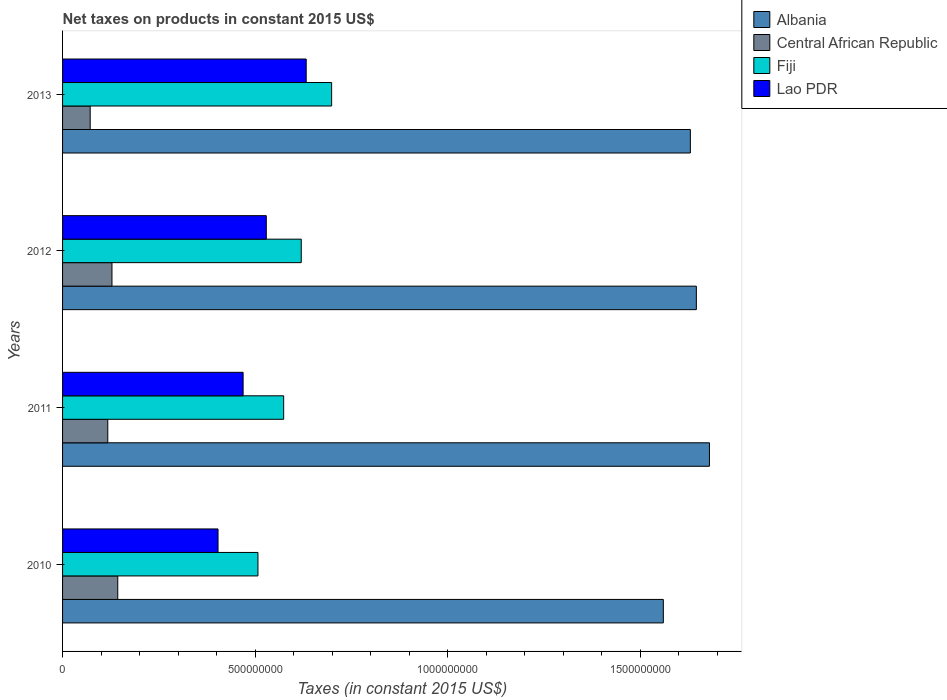How many different coloured bars are there?
Your response must be concise. 4. How many groups of bars are there?
Offer a very short reply. 4. Are the number of bars per tick equal to the number of legend labels?
Ensure brevity in your answer.  Yes. Are the number of bars on each tick of the Y-axis equal?
Offer a terse response. Yes. How many bars are there on the 1st tick from the top?
Ensure brevity in your answer.  4. What is the label of the 1st group of bars from the top?
Give a very brief answer. 2013. What is the net taxes on products in Albania in 2010?
Your answer should be compact. 1.56e+09. Across all years, what is the maximum net taxes on products in Central African Republic?
Keep it short and to the point. 1.43e+08. Across all years, what is the minimum net taxes on products in Lao PDR?
Your response must be concise. 4.04e+08. In which year was the net taxes on products in Albania maximum?
Ensure brevity in your answer.  2011. In which year was the net taxes on products in Central African Republic minimum?
Provide a short and direct response. 2013. What is the total net taxes on products in Fiji in the graph?
Your response must be concise. 2.40e+09. What is the difference between the net taxes on products in Fiji in 2012 and that in 2013?
Offer a very short reply. -7.89e+07. What is the difference between the net taxes on products in Fiji in 2011 and the net taxes on products in Central African Republic in 2012?
Give a very brief answer. 4.46e+08. What is the average net taxes on products in Albania per year?
Ensure brevity in your answer.  1.63e+09. In the year 2012, what is the difference between the net taxes on products in Central African Republic and net taxes on products in Lao PDR?
Make the answer very short. -4.01e+08. In how many years, is the net taxes on products in Central African Republic greater than 700000000 US$?
Provide a short and direct response. 0. What is the ratio of the net taxes on products in Fiji in 2011 to that in 2013?
Provide a short and direct response. 0.82. Is the net taxes on products in Lao PDR in 2010 less than that in 2011?
Provide a short and direct response. Yes. What is the difference between the highest and the second highest net taxes on products in Albania?
Your answer should be very brief. 3.41e+07. What is the difference between the highest and the lowest net taxes on products in Fiji?
Offer a terse response. 1.91e+08. Is it the case that in every year, the sum of the net taxes on products in Lao PDR and net taxes on products in Fiji is greater than the sum of net taxes on products in Central African Republic and net taxes on products in Albania?
Keep it short and to the point. No. What does the 2nd bar from the top in 2011 represents?
Your answer should be compact. Fiji. What does the 4th bar from the bottom in 2011 represents?
Your answer should be compact. Lao PDR. Is it the case that in every year, the sum of the net taxes on products in Fiji and net taxes on products in Central African Republic is greater than the net taxes on products in Albania?
Give a very brief answer. No. What is the difference between two consecutive major ticks on the X-axis?
Offer a terse response. 5.00e+08. Are the values on the major ticks of X-axis written in scientific E-notation?
Ensure brevity in your answer.  No. Does the graph contain any zero values?
Your answer should be compact. No. Does the graph contain grids?
Offer a terse response. No. Where does the legend appear in the graph?
Offer a very short reply. Top right. How many legend labels are there?
Provide a succinct answer. 4. What is the title of the graph?
Keep it short and to the point. Net taxes on products in constant 2015 US$. Does "Afghanistan" appear as one of the legend labels in the graph?
Give a very brief answer. No. What is the label or title of the X-axis?
Offer a very short reply. Taxes (in constant 2015 US$). What is the Taxes (in constant 2015 US$) of Albania in 2010?
Offer a terse response. 1.56e+09. What is the Taxes (in constant 2015 US$) in Central African Republic in 2010?
Your answer should be very brief. 1.43e+08. What is the Taxes (in constant 2015 US$) of Fiji in 2010?
Offer a terse response. 5.07e+08. What is the Taxes (in constant 2015 US$) of Lao PDR in 2010?
Offer a very short reply. 4.04e+08. What is the Taxes (in constant 2015 US$) in Albania in 2011?
Your response must be concise. 1.68e+09. What is the Taxes (in constant 2015 US$) in Central African Republic in 2011?
Make the answer very short. 1.17e+08. What is the Taxes (in constant 2015 US$) of Fiji in 2011?
Keep it short and to the point. 5.74e+08. What is the Taxes (in constant 2015 US$) of Lao PDR in 2011?
Keep it short and to the point. 4.69e+08. What is the Taxes (in constant 2015 US$) in Albania in 2012?
Keep it short and to the point. 1.65e+09. What is the Taxes (in constant 2015 US$) in Central African Republic in 2012?
Offer a terse response. 1.28e+08. What is the Taxes (in constant 2015 US$) in Fiji in 2012?
Your response must be concise. 6.20e+08. What is the Taxes (in constant 2015 US$) in Lao PDR in 2012?
Offer a very short reply. 5.29e+08. What is the Taxes (in constant 2015 US$) in Albania in 2013?
Ensure brevity in your answer.  1.63e+09. What is the Taxes (in constant 2015 US$) in Central African Republic in 2013?
Keep it short and to the point. 7.17e+07. What is the Taxes (in constant 2015 US$) of Fiji in 2013?
Ensure brevity in your answer.  6.99e+08. What is the Taxes (in constant 2015 US$) of Lao PDR in 2013?
Give a very brief answer. 6.33e+08. Across all years, what is the maximum Taxes (in constant 2015 US$) in Albania?
Your answer should be very brief. 1.68e+09. Across all years, what is the maximum Taxes (in constant 2015 US$) of Central African Republic?
Make the answer very short. 1.43e+08. Across all years, what is the maximum Taxes (in constant 2015 US$) of Fiji?
Your answer should be compact. 6.99e+08. Across all years, what is the maximum Taxes (in constant 2015 US$) in Lao PDR?
Your answer should be very brief. 6.33e+08. Across all years, what is the minimum Taxes (in constant 2015 US$) in Albania?
Your answer should be compact. 1.56e+09. Across all years, what is the minimum Taxes (in constant 2015 US$) of Central African Republic?
Ensure brevity in your answer.  7.17e+07. Across all years, what is the minimum Taxes (in constant 2015 US$) in Fiji?
Make the answer very short. 5.07e+08. Across all years, what is the minimum Taxes (in constant 2015 US$) in Lao PDR?
Ensure brevity in your answer.  4.04e+08. What is the total Taxes (in constant 2015 US$) in Albania in the graph?
Your answer should be very brief. 6.52e+09. What is the total Taxes (in constant 2015 US$) in Central African Republic in the graph?
Provide a succinct answer. 4.61e+08. What is the total Taxes (in constant 2015 US$) in Fiji in the graph?
Keep it short and to the point. 2.40e+09. What is the total Taxes (in constant 2015 US$) in Lao PDR in the graph?
Provide a succinct answer. 2.03e+09. What is the difference between the Taxes (in constant 2015 US$) of Albania in 2010 and that in 2011?
Your answer should be compact. -1.20e+08. What is the difference between the Taxes (in constant 2015 US$) of Central African Republic in 2010 and that in 2011?
Your answer should be compact. 2.59e+07. What is the difference between the Taxes (in constant 2015 US$) in Fiji in 2010 and that in 2011?
Your answer should be very brief. -6.68e+07. What is the difference between the Taxes (in constant 2015 US$) of Lao PDR in 2010 and that in 2011?
Make the answer very short. -6.51e+07. What is the difference between the Taxes (in constant 2015 US$) of Albania in 2010 and that in 2012?
Make the answer very short. -8.57e+07. What is the difference between the Taxes (in constant 2015 US$) of Central African Republic in 2010 and that in 2012?
Offer a very short reply. 1.51e+07. What is the difference between the Taxes (in constant 2015 US$) in Fiji in 2010 and that in 2012?
Give a very brief answer. -1.12e+08. What is the difference between the Taxes (in constant 2015 US$) of Lao PDR in 2010 and that in 2012?
Provide a succinct answer. -1.25e+08. What is the difference between the Taxes (in constant 2015 US$) of Albania in 2010 and that in 2013?
Ensure brevity in your answer.  -7.02e+07. What is the difference between the Taxes (in constant 2015 US$) of Central African Republic in 2010 and that in 2013?
Provide a succinct answer. 7.16e+07. What is the difference between the Taxes (in constant 2015 US$) of Fiji in 2010 and that in 2013?
Your response must be concise. -1.91e+08. What is the difference between the Taxes (in constant 2015 US$) of Lao PDR in 2010 and that in 2013?
Offer a terse response. -2.29e+08. What is the difference between the Taxes (in constant 2015 US$) of Albania in 2011 and that in 2012?
Provide a succinct answer. 3.41e+07. What is the difference between the Taxes (in constant 2015 US$) of Central African Republic in 2011 and that in 2012?
Ensure brevity in your answer.  -1.09e+07. What is the difference between the Taxes (in constant 2015 US$) of Fiji in 2011 and that in 2012?
Your answer should be compact. -4.56e+07. What is the difference between the Taxes (in constant 2015 US$) of Lao PDR in 2011 and that in 2012?
Give a very brief answer. -6.02e+07. What is the difference between the Taxes (in constant 2015 US$) of Albania in 2011 and that in 2013?
Provide a short and direct response. 4.96e+07. What is the difference between the Taxes (in constant 2015 US$) in Central African Republic in 2011 and that in 2013?
Offer a terse response. 4.57e+07. What is the difference between the Taxes (in constant 2015 US$) in Fiji in 2011 and that in 2013?
Your answer should be compact. -1.25e+08. What is the difference between the Taxes (in constant 2015 US$) of Lao PDR in 2011 and that in 2013?
Your answer should be very brief. -1.64e+08. What is the difference between the Taxes (in constant 2015 US$) of Albania in 2012 and that in 2013?
Ensure brevity in your answer.  1.55e+07. What is the difference between the Taxes (in constant 2015 US$) of Central African Republic in 2012 and that in 2013?
Your answer should be compact. 5.66e+07. What is the difference between the Taxes (in constant 2015 US$) of Fiji in 2012 and that in 2013?
Keep it short and to the point. -7.89e+07. What is the difference between the Taxes (in constant 2015 US$) in Lao PDR in 2012 and that in 2013?
Ensure brevity in your answer.  -1.04e+08. What is the difference between the Taxes (in constant 2015 US$) of Albania in 2010 and the Taxes (in constant 2015 US$) of Central African Republic in 2011?
Ensure brevity in your answer.  1.44e+09. What is the difference between the Taxes (in constant 2015 US$) in Albania in 2010 and the Taxes (in constant 2015 US$) in Fiji in 2011?
Your response must be concise. 9.86e+08. What is the difference between the Taxes (in constant 2015 US$) in Albania in 2010 and the Taxes (in constant 2015 US$) in Lao PDR in 2011?
Offer a terse response. 1.09e+09. What is the difference between the Taxes (in constant 2015 US$) of Central African Republic in 2010 and the Taxes (in constant 2015 US$) of Fiji in 2011?
Keep it short and to the point. -4.31e+08. What is the difference between the Taxes (in constant 2015 US$) in Central African Republic in 2010 and the Taxes (in constant 2015 US$) in Lao PDR in 2011?
Provide a succinct answer. -3.26e+08. What is the difference between the Taxes (in constant 2015 US$) of Fiji in 2010 and the Taxes (in constant 2015 US$) of Lao PDR in 2011?
Make the answer very short. 3.86e+07. What is the difference between the Taxes (in constant 2015 US$) of Albania in 2010 and the Taxes (in constant 2015 US$) of Central African Republic in 2012?
Make the answer very short. 1.43e+09. What is the difference between the Taxes (in constant 2015 US$) in Albania in 2010 and the Taxes (in constant 2015 US$) in Fiji in 2012?
Give a very brief answer. 9.40e+08. What is the difference between the Taxes (in constant 2015 US$) of Albania in 2010 and the Taxes (in constant 2015 US$) of Lao PDR in 2012?
Provide a succinct answer. 1.03e+09. What is the difference between the Taxes (in constant 2015 US$) of Central African Republic in 2010 and the Taxes (in constant 2015 US$) of Fiji in 2012?
Your answer should be very brief. -4.77e+08. What is the difference between the Taxes (in constant 2015 US$) of Central African Republic in 2010 and the Taxes (in constant 2015 US$) of Lao PDR in 2012?
Your response must be concise. -3.86e+08. What is the difference between the Taxes (in constant 2015 US$) of Fiji in 2010 and the Taxes (in constant 2015 US$) of Lao PDR in 2012?
Your response must be concise. -2.17e+07. What is the difference between the Taxes (in constant 2015 US$) of Albania in 2010 and the Taxes (in constant 2015 US$) of Central African Republic in 2013?
Your answer should be compact. 1.49e+09. What is the difference between the Taxes (in constant 2015 US$) in Albania in 2010 and the Taxes (in constant 2015 US$) in Fiji in 2013?
Your answer should be compact. 8.61e+08. What is the difference between the Taxes (in constant 2015 US$) of Albania in 2010 and the Taxes (in constant 2015 US$) of Lao PDR in 2013?
Your response must be concise. 9.27e+08. What is the difference between the Taxes (in constant 2015 US$) in Central African Republic in 2010 and the Taxes (in constant 2015 US$) in Fiji in 2013?
Offer a terse response. -5.55e+08. What is the difference between the Taxes (in constant 2015 US$) in Central African Republic in 2010 and the Taxes (in constant 2015 US$) in Lao PDR in 2013?
Your answer should be compact. -4.89e+08. What is the difference between the Taxes (in constant 2015 US$) of Fiji in 2010 and the Taxes (in constant 2015 US$) of Lao PDR in 2013?
Make the answer very short. -1.25e+08. What is the difference between the Taxes (in constant 2015 US$) of Albania in 2011 and the Taxes (in constant 2015 US$) of Central African Republic in 2012?
Offer a very short reply. 1.55e+09. What is the difference between the Taxes (in constant 2015 US$) in Albania in 2011 and the Taxes (in constant 2015 US$) in Fiji in 2012?
Provide a short and direct response. 1.06e+09. What is the difference between the Taxes (in constant 2015 US$) in Albania in 2011 and the Taxes (in constant 2015 US$) in Lao PDR in 2012?
Give a very brief answer. 1.15e+09. What is the difference between the Taxes (in constant 2015 US$) of Central African Republic in 2011 and the Taxes (in constant 2015 US$) of Fiji in 2012?
Provide a short and direct response. -5.02e+08. What is the difference between the Taxes (in constant 2015 US$) of Central African Republic in 2011 and the Taxes (in constant 2015 US$) of Lao PDR in 2012?
Keep it short and to the point. -4.12e+08. What is the difference between the Taxes (in constant 2015 US$) in Fiji in 2011 and the Taxes (in constant 2015 US$) in Lao PDR in 2012?
Keep it short and to the point. 4.51e+07. What is the difference between the Taxes (in constant 2015 US$) in Albania in 2011 and the Taxes (in constant 2015 US$) in Central African Republic in 2013?
Offer a very short reply. 1.61e+09. What is the difference between the Taxes (in constant 2015 US$) of Albania in 2011 and the Taxes (in constant 2015 US$) of Fiji in 2013?
Keep it short and to the point. 9.81e+08. What is the difference between the Taxes (in constant 2015 US$) of Albania in 2011 and the Taxes (in constant 2015 US$) of Lao PDR in 2013?
Your response must be concise. 1.05e+09. What is the difference between the Taxes (in constant 2015 US$) in Central African Republic in 2011 and the Taxes (in constant 2015 US$) in Fiji in 2013?
Give a very brief answer. -5.81e+08. What is the difference between the Taxes (in constant 2015 US$) in Central African Republic in 2011 and the Taxes (in constant 2015 US$) in Lao PDR in 2013?
Keep it short and to the point. -5.15e+08. What is the difference between the Taxes (in constant 2015 US$) in Fiji in 2011 and the Taxes (in constant 2015 US$) in Lao PDR in 2013?
Make the answer very short. -5.85e+07. What is the difference between the Taxes (in constant 2015 US$) of Albania in 2012 and the Taxes (in constant 2015 US$) of Central African Republic in 2013?
Provide a short and direct response. 1.57e+09. What is the difference between the Taxes (in constant 2015 US$) in Albania in 2012 and the Taxes (in constant 2015 US$) in Fiji in 2013?
Your response must be concise. 9.47e+08. What is the difference between the Taxes (in constant 2015 US$) of Albania in 2012 and the Taxes (in constant 2015 US$) of Lao PDR in 2013?
Your answer should be compact. 1.01e+09. What is the difference between the Taxes (in constant 2015 US$) in Central African Republic in 2012 and the Taxes (in constant 2015 US$) in Fiji in 2013?
Make the answer very short. -5.70e+08. What is the difference between the Taxes (in constant 2015 US$) in Central African Republic in 2012 and the Taxes (in constant 2015 US$) in Lao PDR in 2013?
Keep it short and to the point. -5.04e+08. What is the difference between the Taxes (in constant 2015 US$) of Fiji in 2012 and the Taxes (in constant 2015 US$) of Lao PDR in 2013?
Ensure brevity in your answer.  -1.29e+07. What is the average Taxes (in constant 2015 US$) in Albania per year?
Keep it short and to the point. 1.63e+09. What is the average Taxes (in constant 2015 US$) in Central African Republic per year?
Offer a terse response. 1.15e+08. What is the average Taxes (in constant 2015 US$) of Fiji per year?
Ensure brevity in your answer.  6.00e+08. What is the average Taxes (in constant 2015 US$) of Lao PDR per year?
Ensure brevity in your answer.  5.09e+08. In the year 2010, what is the difference between the Taxes (in constant 2015 US$) of Albania and Taxes (in constant 2015 US$) of Central African Republic?
Provide a short and direct response. 1.42e+09. In the year 2010, what is the difference between the Taxes (in constant 2015 US$) of Albania and Taxes (in constant 2015 US$) of Fiji?
Provide a succinct answer. 1.05e+09. In the year 2010, what is the difference between the Taxes (in constant 2015 US$) of Albania and Taxes (in constant 2015 US$) of Lao PDR?
Give a very brief answer. 1.16e+09. In the year 2010, what is the difference between the Taxes (in constant 2015 US$) of Central African Republic and Taxes (in constant 2015 US$) of Fiji?
Give a very brief answer. -3.64e+08. In the year 2010, what is the difference between the Taxes (in constant 2015 US$) in Central African Republic and Taxes (in constant 2015 US$) in Lao PDR?
Provide a short and direct response. -2.60e+08. In the year 2010, what is the difference between the Taxes (in constant 2015 US$) in Fiji and Taxes (in constant 2015 US$) in Lao PDR?
Your response must be concise. 1.04e+08. In the year 2011, what is the difference between the Taxes (in constant 2015 US$) of Albania and Taxes (in constant 2015 US$) of Central African Republic?
Offer a very short reply. 1.56e+09. In the year 2011, what is the difference between the Taxes (in constant 2015 US$) of Albania and Taxes (in constant 2015 US$) of Fiji?
Your response must be concise. 1.11e+09. In the year 2011, what is the difference between the Taxes (in constant 2015 US$) in Albania and Taxes (in constant 2015 US$) in Lao PDR?
Your response must be concise. 1.21e+09. In the year 2011, what is the difference between the Taxes (in constant 2015 US$) of Central African Republic and Taxes (in constant 2015 US$) of Fiji?
Your answer should be very brief. -4.57e+08. In the year 2011, what is the difference between the Taxes (in constant 2015 US$) of Central African Republic and Taxes (in constant 2015 US$) of Lao PDR?
Ensure brevity in your answer.  -3.51e+08. In the year 2011, what is the difference between the Taxes (in constant 2015 US$) of Fiji and Taxes (in constant 2015 US$) of Lao PDR?
Give a very brief answer. 1.05e+08. In the year 2012, what is the difference between the Taxes (in constant 2015 US$) of Albania and Taxes (in constant 2015 US$) of Central African Republic?
Your answer should be very brief. 1.52e+09. In the year 2012, what is the difference between the Taxes (in constant 2015 US$) in Albania and Taxes (in constant 2015 US$) in Fiji?
Your answer should be very brief. 1.03e+09. In the year 2012, what is the difference between the Taxes (in constant 2015 US$) of Albania and Taxes (in constant 2015 US$) of Lao PDR?
Give a very brief answer. 1.12e+09. In the year 2012, what is the difference between the Taxes (in constant 2015 US$) of Central African Republic and Taxes (in constant 2015 US$) of Fiji?
Your answer should be very brief. -4.92e+08. In the year 2012, what is the difference between the Taxes (in constant 2015 US$) in Central African Republic and Taxes (in constant 2015 US$) in Lao PDR?
Ensure brevity in your answer.  -4.01e+08. In the year 2012, what is the difference between the Taxes (in constant 2015 US$) of Fiji and Taxes (in constant 2015 US$) of Lao PDR?
Offer a terse response. 9.08e+07. In the year 2013, what is the difference between the Taxes (in constant 2015 US$) in Albania and Taxes (in constant 2015 US$) in Central African Republic?
Keep it short and to the point. 1.56e+09. In the year 2013, what is the difference between the Taxes (in constant 2015 US$) of Albania and Taxes (in constant 2015 US$) of Fiji?
Offer a terse response. 9.32e+08. In the year 2013, what is the difference between the Taxes (in constant 2015 US$) of Albania and Taxes (in constant 2015 US$) of Lao PDR?
Give a very brief answer. 9.98e+08. In the year 2013, what is the difference between the Taxes (in constant 2015 US$) of Central African Republic and Taxes (in constant 2015 US$) of Fiji?
Ensure brevity in your answer.  -6.27e+08. In the year 2013, what is the difference between the Taxes (in constant 2015 US$) in Central African Republic and Taxes (in constant 2015 US$) in Lao PDR?
Offer a very short reply. -5.61e+08. In the year 2013, what is the difference between the Taxes (in constant 2015 US$) of Fiji and Taxes (in constant 2015 US$) of Lao PDR?
Offer a terse response. 6.60e+07. What is the ratio of the Taxes (in constant 2015 US$) of Albania in 2010 to that in 2011?
Provide a short and direct response. 0.93. What is the ratio of the Taxes (in constant 2015 US$) in Central African Republic in 2010 to that in 2011?
Make the answer very short. 1.22. What is the ratio of the Taxes (in constant 2015 US$) in Fiji in 2010 to that in 2011?
Give a very brief answer. 0.88. What is the ratio of the Taxes (in constant 2015 US$) of Lao PDR in 2010 to that in 2011?
Your response must be concise. 0.86. What is the ratio of the Taxes (in constant 2015 US$) of Albania in 2010 to that in 2012?
Keep it short and to the point. 0.95. What is the ratio of the Taxes (in constant 2015 US$) in Central African Republic in 2010 to that in 2012?
Offer a terse response. 1.12. What is the ratio of the Taxes (in constant 2015 US$) of Fiji in 2010 to that in 2012?
Make the answer very short. 0.82. What is the ratio of the Taxes (in constant 2015 US$) in Lao PDR in 2010 to that in 2012?
Your answer should be very brief. 0.76. What is the ratio of the Taxes (in constant 2015 US$) of Albania in 2010 to that in 2013?
Make the answer very short. 0.96. What is the ratio of the Taxes (in constant 2015 US$) in Central African Republic in 2010 to that in 2013?
Your answer should be compact. 2. What is the ratio of the Taxes (in constant 2015 US$) of Fiji in 2010 to that in 2013?
Give a very brief answer. 0.73. What is the ratio of the Taxes (in constant 2015 US$) of Lao PDR in 2010 to that in 2013?
Provide a succinct answer. 0.64. What is the ratio of the Taxes (in constant 2015 US$) of Albania in 2011 to that in 2012?
Your answer should be compact. 1.02. What is the ratio of the Taxes (in constant 2015 US$) of Central African Republic in 2011 to that in 2012?
Keep it short and to the point. 0.92. What is the ratio of the Taxes (in constant 2015 US$) of Fiji in 2011 to that in 2012?
Make the answer very short. 0.93. What is the ratio of the Taxes (in constant 2015 US$) in Lao PDR in 2011 to that in 2012?
Your answer should be compact. 0.89. What is the ratio of the Taxes (in constant 2015 US$) in Albania in 2011 to that in 2013?
Make the answer very short. 1.03. What is the ratio of the Taxes (in constant 2015 US$) of Central African Republic in 2011 to that in 2013?
Offer a very short reply. 1.64. What is the ratio of the Taxes (in constant 2015 US$) in Fiji in 2011 to that in 2013?
Keep it short and to the point. 0.82. What is the ratio of the Taxes (in constant 2015 US$) in Lao PDR in 2011 to that in 2013?
Give a very brief answer. 0.74. What is the ratio of the Taxes (in constant 2015 US$) in Albania in 2012 to that in 2013?
Give a very brief answer. 1.01. What is the ratio of the Taxes (in constant 2015 US$) in Central African Republic in 2012 to that in 2013?
Offer a terse response. 1.79. What is the ratio of the Taxes (in constant 2015 US$) of Fiji in 2012 to that in 2013?
Your response must be concise. 0.89. What is the ratio of the Taxes (in constant 2015 US$) in Lao PDR in 2012 to that in 2013?
Your answer should be very brief. 0.84. What is the difference between the highest and the second highest Taxes (in constant 2015 US$) of Albania?
Give a very brief answer. 3.41e+07. What is the difference between the highest and the second highest Taxes (in constant 2015 US$) in Central African Republic?
Offer a very short reply. 1.51e+07. What is the difference between the highest and the second highest Taxes (in constant 2015 US$) of Fiji?
Offer a terse response. 7.89e+07. What is the difference between the highest and the second highest Taxes (in constant 2015 US$) of Lao PDR?
Give a very brief answer. 1.04e+08. What is the difference between the highest and the lowest Taxes (in constant 2015 US$) in Albania?
Give a very brief answer. 1.20e+08. What is the difference between the highest and the lowest Taxes (in constant 2015 US$) in Central African Republic?
Keep it short and to the point. 7.16e+07. What is the difference between the highest and the lowest Taxes (in constant 2015 US$) of Fiji?
Give a very brief answer. 1.91e+08. What is the difference between the highest and the lowest Taxes (in constant 2015 US$) in Lao PDR?
Provide a short and direct response. 2.29e+08. 